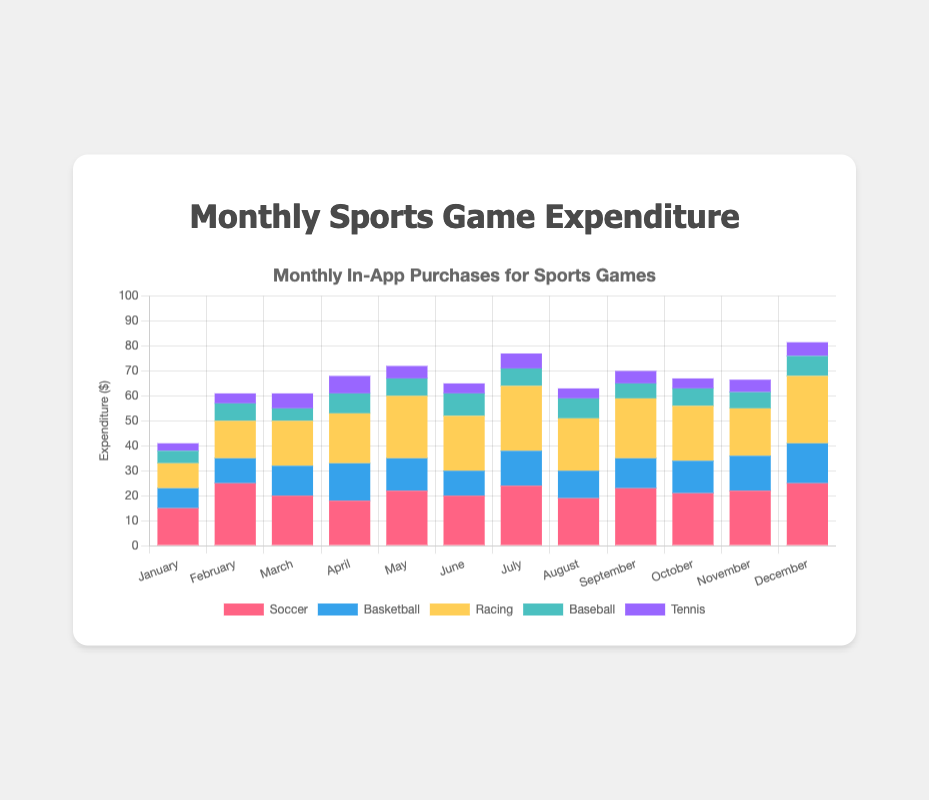What's the total expenditure on in-app purchases for Soccer in the entire year? Sum up the expenditures on Soccer for each month: 15 + 25 + 20 + 18 + 22 + 20 + 24 + 19 + 23 + 21 + 22 + 25. This equals 254.
Answer: 254 Which month had the highest total expenditure on in-app purchases? Add the expenditures for all the game types each month and compare: January (41), February (61), March (61), April (68), May (72), June (65), July (77), August (63), September (70), October (67), November (66.5), December (81.5). The highest expenditure is in December.
Answer: December Which game type had the highest average monthly expenditure? Calculate the average expenditure for each game type across 12 months: Soccer (21.17), Basketball (12.5), Racing (19.25), Baseball (7.04), Tennis (4.67). Soccer has the highest average monthly expenditure.
Answer: Soccer In which month was the expenditure on Racing games highest, and what was the amount? Check the Racing expenditure for each month: January (10), February (15), March (18), April (20), May (25), June (22), July (26), August (21), September (24), October (22), November (19), December (27). The highest was in December at 27.
Answer: December, 27 Did the expenditure on Basketball games ever exceed the expenditure on Soccer games in any month? Compare Soccer and Basketball expenditures for each month: 
 January (15 vs 8), February (25 vs 10), March (20 vs 12), April (18 vs 15), May (22 vs 13), June (20 vs 10), July (24 vs 14), August (19 vs 11), September (23 vs 12), October (21 vs 13), November (22 vs 14), December (25 vs 16). No, Basketball expenditure never exceeded Soccer expenditure.
Answer: No What's the difference in total annual expenditure between Racing and Baseball games? Calculate the total annual expenditure for Racing (219) and Baseball (92.5). The difference is 219 - 92.5 = 126.5.
Answer: 126.5 Which game type had the most consistent expenditure across all months? Check the data for the smallest variance or range in monthly expenditures: 
Soccer (10), Basketball (8), Racing (17), Baseball (4), Tennis (4). Tennis and Baseball have equally the smallest variance in expenditures at 4.
Answer: Tennis and Baseball In which months did Soccer game expenditures exceed $20? Check Soccer expenditures exceeding $20: February (25), May (22), June (20), July (24), September (23), November (22), December (25). These months are February, May, July, September, November, and December.
Answer: February, May, July, September, November, December Which month had the highest expenditure on Tennis games and what was the amount? Check Tennis expenditures for each month: January (3), February (4), March (6), April (7), May (5), June (4), July (6), August (4), September (5), October (4), November (5), December (5.5). The highest was in April at 7.
Answer: April, 7 